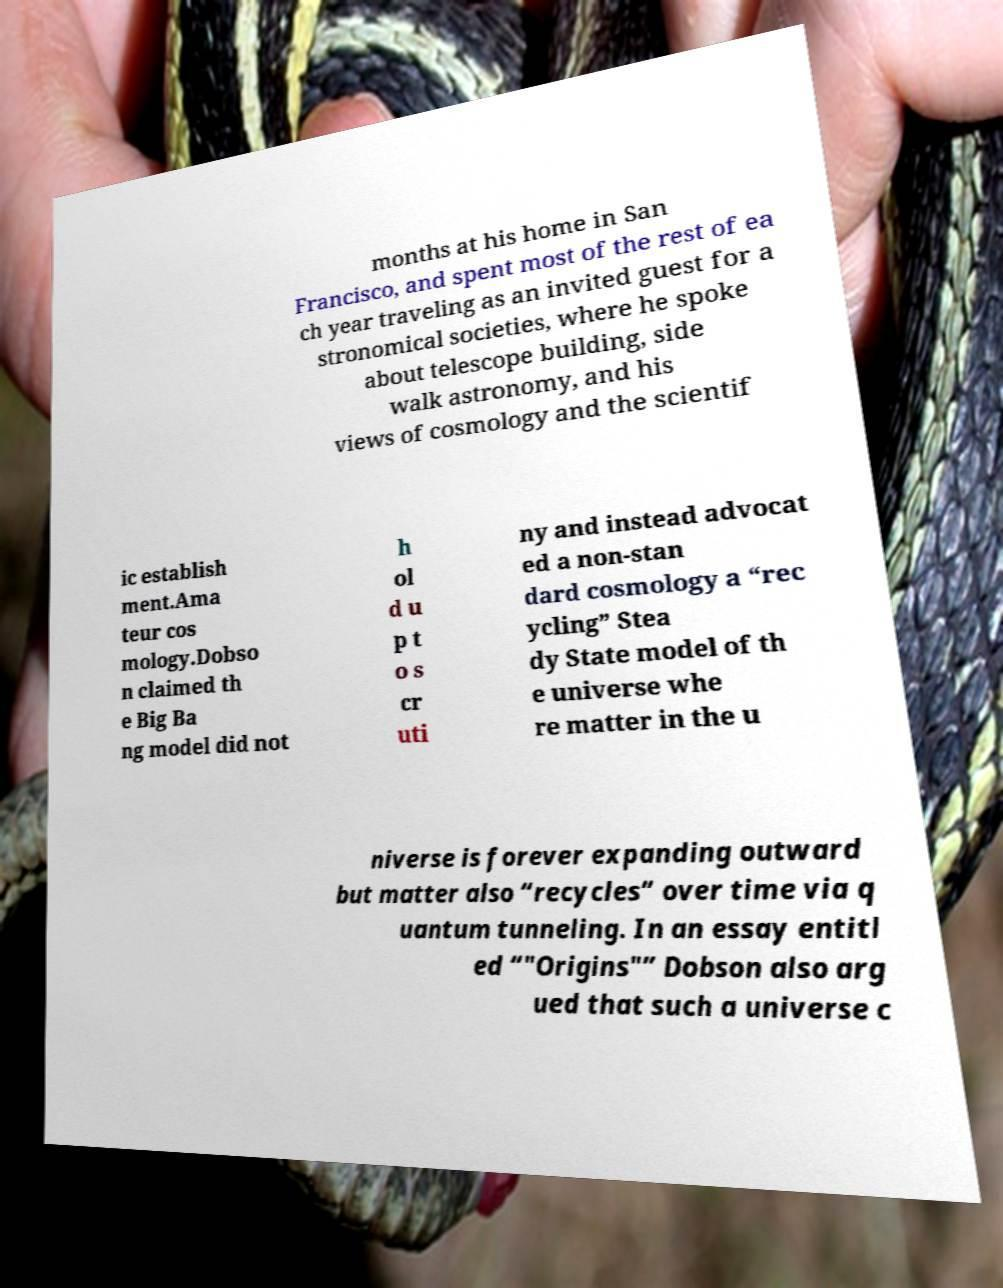Could you assist in decoding the text presented in this image and type it out clearly? months at his home in San Francisco, and spent most of the rest of ea ch year traveling as an invited guest for a stronomical societies, where he spoke about telescope building, side walk astronomy, and his views of cosmology and the scientif ic establish ment.Ama teur cos mology.Dobso n claimed th e Big Ba ng model did not h ol d u p t o s cr uti ny and instead advocat ed a non-stan dard cosmology a “rec ycling” Stea dy State model of th e universe whe re matter in the u niverse is forever expanding outward but matter also “recycles” over time via q uantum tunneling. In an essay entitl ed “"Origins"” Dobson also arg ued that such a universe c 